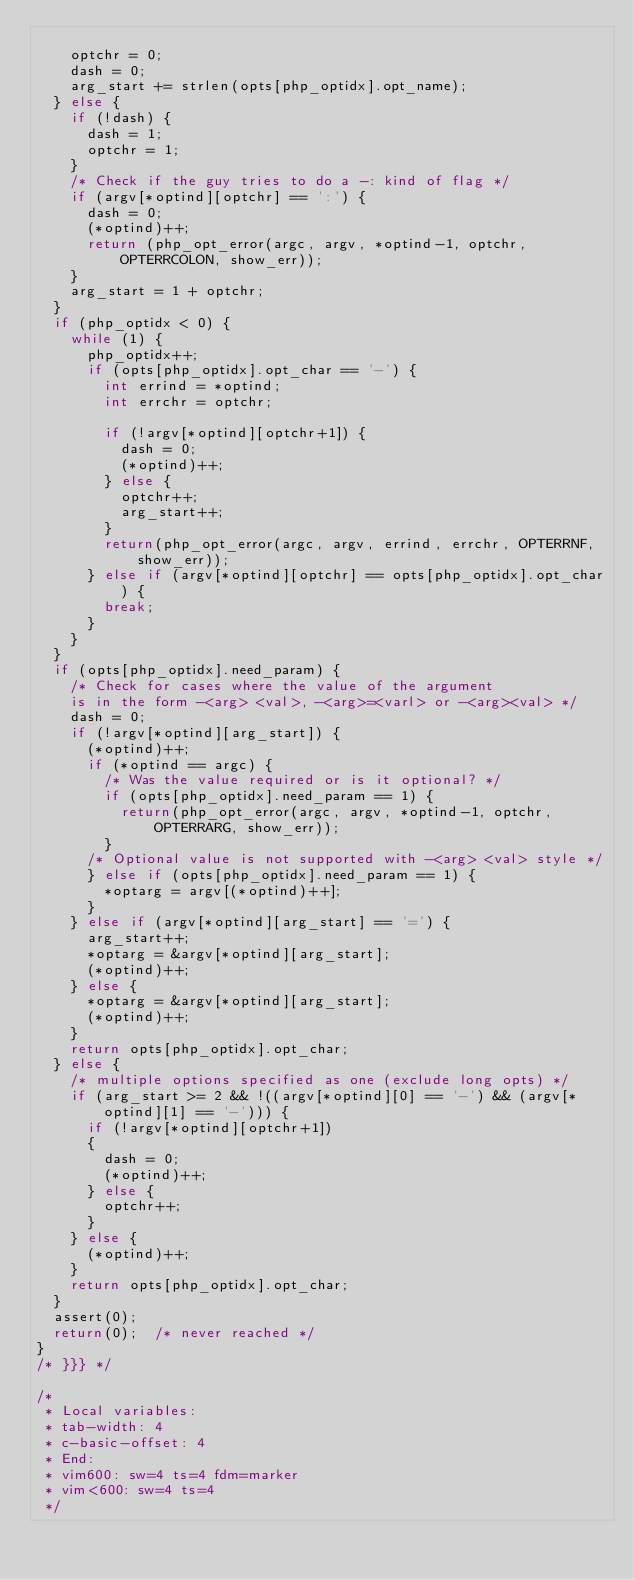<code> <loc_0><loc_0><loc_500><loc_500><_C_>
		optchr = 0;
		dash = 0;
		arg_start += strlen(opts[php_optidx].opt_name);
	} else {
		if (!dash) {
			dash = 1;
			optchr = 1;
		}
		/* Check if the guy tries to do a -: kind of flag */
		if (argv[*optind][optchr] == ':') {
			dash = 0;
			(*optind)++;
			return (php_opt_error(argc, argv, *optind-1, optchr, OPTERRCOLON, show_err));
		}
		arg_start = 1 + optchr;
	}
	if (php_optidx < 0) {
		while (1) {
			php_optidx++;
			if (opts[php_optidx].opt_char == '-') {
				int errind = *optind;
				int errchr = optchr;

				if (!argv[*optind][optchr+1]) {
					dash = 0;
					(*optind)++;
				} else {
					optchr++;
					arg_start++;
				}
				return(php_opt_error(argc, argv, errind, errchr, OPTERRNF, show_err));
			} else if (argv[*optind][optchr] == opts[php_optidx].opt_char) {
				break;
			}
		}
	}
	if (opts[php_optidx].need_param) {
		/* Check for cases where the value of the argument
		is in the form -<arg> <val>, -<arg>=<varl> or -<arg><val> */
		dash = 0;
		if (!argv[*optind][arg_start]) {
			(*optind)++;
			if (*optind == argc) {
				/* Was the value required or is it optional? */
				if (opts[php_optidx].need_param == 1) {
					return(php_opt_error(argc, argv, *optind-1, optchr, OPTERRARG, show_err));
				}
			/* Optional value is not supported with -<arg> <val> style */
			} else if (opts[php_optidx].need_param == 1) {
				*optarg = argv[(*optind)++];
 			}
		} else if (argv[*optind][arg_start] == '=') {
			arg_start++;
			*optarg = &argv[*optind][arg_start];
			(*optind)++;
		} else {
			*optarg = &argv[*optind][arg_start];
			(*optind)++;
		}
		return opts[php_optidx].opt_char;
	} else {
		/* multiple options specified as one (exclude long opts) */
		if (arg_start >= 2 && !((argv[*optind][0] == '-') && (argv[*optind][1] == '-'))) {
			if (!argv[*optind][optchr+1])
			{
				dash = 0;
				(*optind)++;
			} else {
				optchr++;
			}
		} else {
			(*optind)++;
		}
		return opts[php_optidx].opt_char;
	}
	assert(0);
	return(0);	/* never reached */
}
/* }}} */

/*
 * Local variables:
 * tab-width: 4
 * c-basic-offset: 4
 * End:
 * vim600: sw=4 ts=4 fdm=marker
 * vim<600: sw=4 ts=4
 */
</code> 